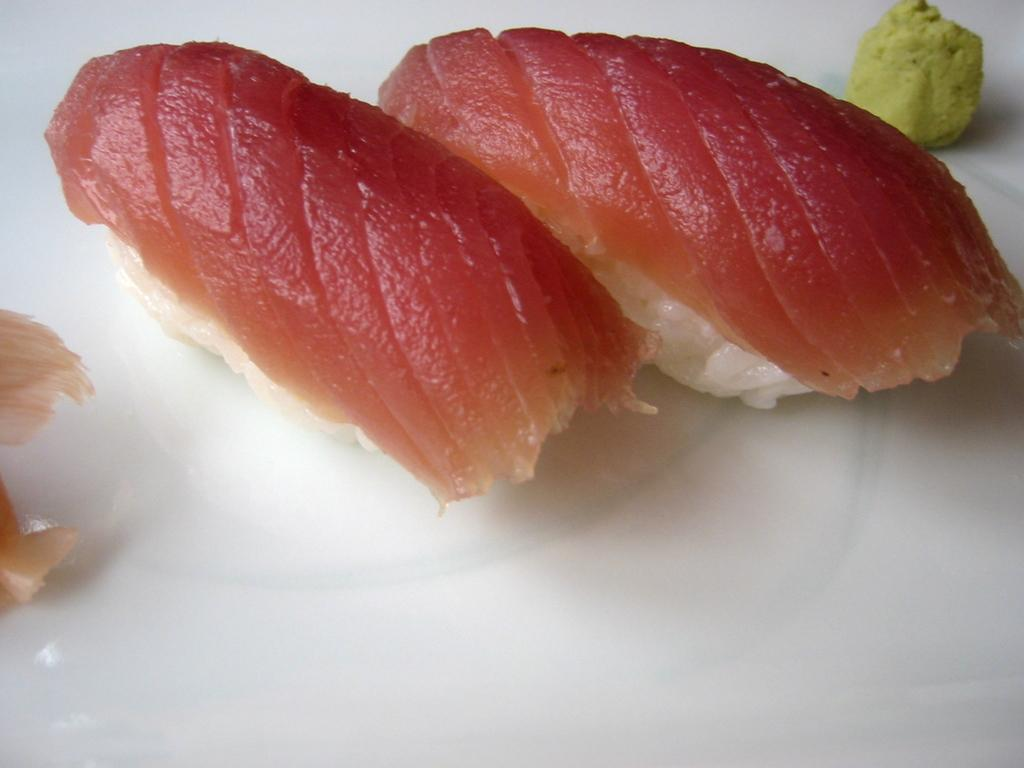What is on the plate that is visible in the image? There is food placed on a plate in the image. Where is the plate located in the image? The plate is located in the center of the image. What type of pollution can be seen in the image? There is no pollution visible in the image; it only features a plate with food on it. How does the behavior of the food on the plate change throughout the day? The food on the plate does not exhibit any behavior, as it is an inanimate object. 